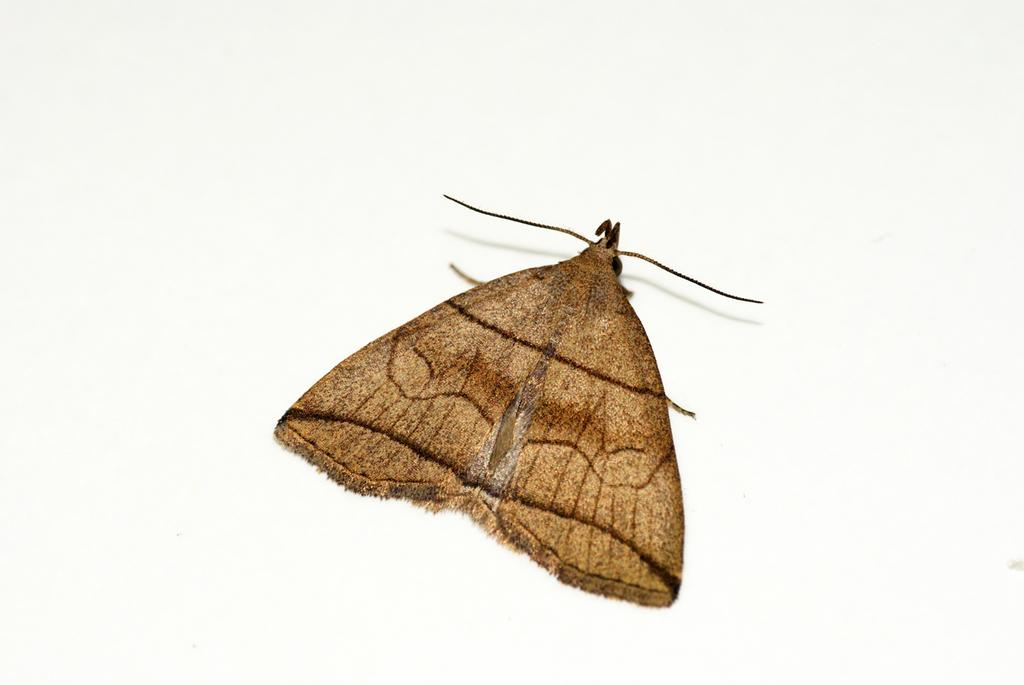What type of creature is present in the image? There is an insect in the image. What is the color of the surface where the insect is located? The insect is on a white color surface. What type of power does the insect generate in the image? The insect does not generate any power in the image; it is simply an insect on a white surface. 